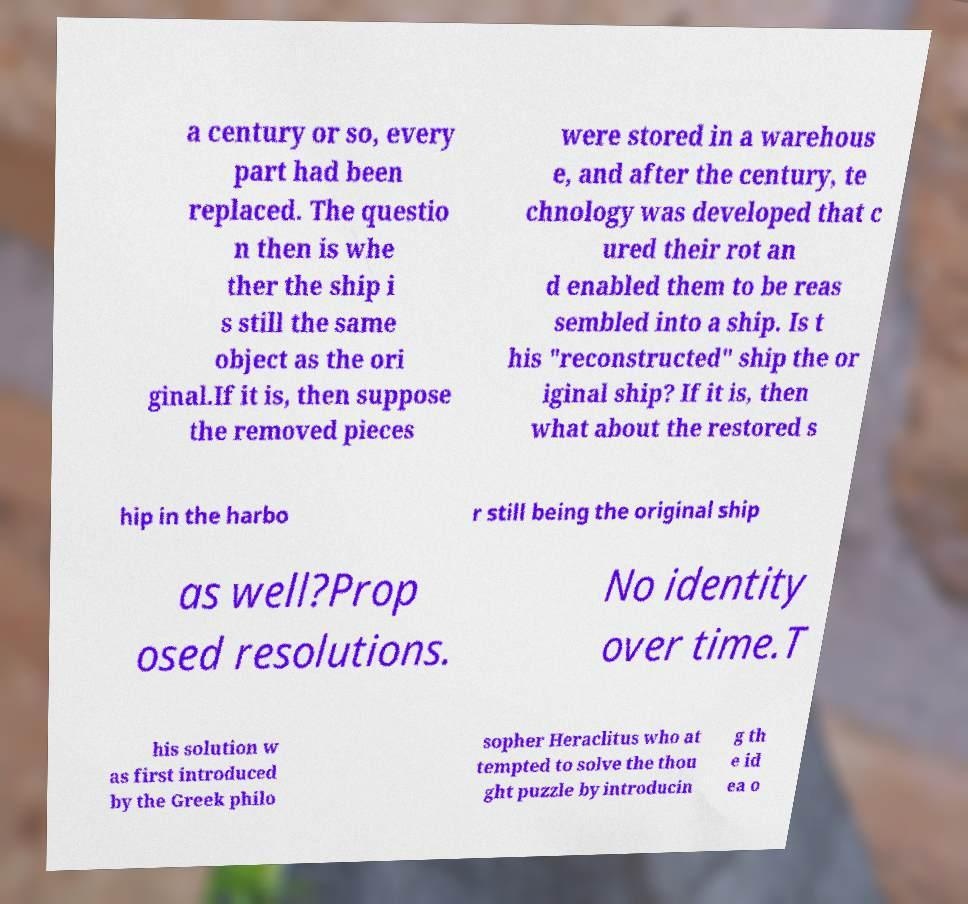For documentation purposes, I need the text within this image transcribed. Could you provide that? a century or so, every part had been replaced. The questio n then is whe ther the ship i s still the same object as the ori ginal.If it is, then suppose the removed pieces were stored in a warehous e, and after the century, te chnology was developed that c ured their rot an d enabled them to be reas sembled into a ship. Is t his "reconstructed" ship the or iginal ship? If it is, then what about the restored s hip in the harbo r still being the original ship as well?Prop osed resolutions. No identity over time.T his solution w as first introduced by the Greek philo sopher Heraclitus who at tempted to solve the thou ght puzzle by introducin g th e id ea o 